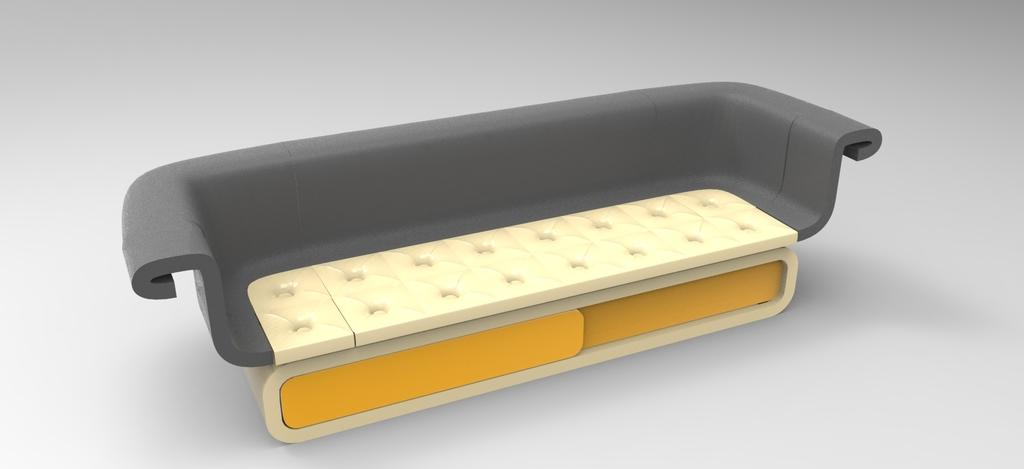What is the main object in the middle of the picture? There is a sofa in the middle of the picture. How would you describe the style of the image? The image is graphical in nature. What color is the background of the image? The background of the image is in grey color. How many bridges can be seen in the image? There are no bridges present in the image. What type of yarn is being used to create the sofa in the image? The image is graphical in nature, and there is no yarn or any material mentioned for the sofa. 